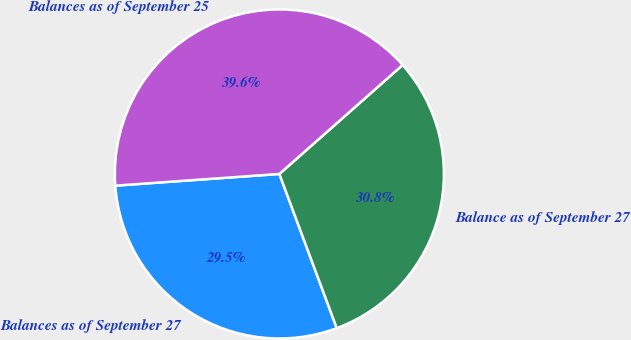Convert chart. <chart><loc_0><loc_0><loc_500><loc_500><pie_chart><fcel>Balances as of September 27<fcel>Balance as of September 27<fcel>Balances as of September 25<nl><fcel>29.54%<fcel>30.85%<fcel>39.61%<nl></chart> 